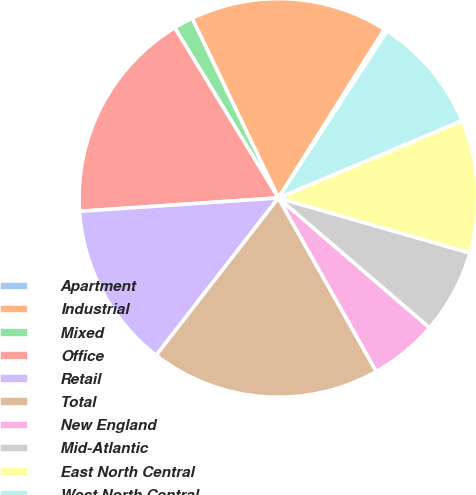Convert chart. <chart><loc_0><loc_0><loc_500><loc_500><pie_chart><fcel>Apartment<fcel>Industrial<fcel>Mixed<fcel>Office<fcel>Retail<fcel>Total<fcel>New England<fcel>Mid-Atlantic<fcel>East North Central<fcel>West North Central<nl><fcel>0.27%<fcel>16.05%<fcel>1.58%<fcel>17.36%<fcel>13.42%<fcel>18.68%<fcel>5.53%<fcel>6.84%<fcel>10.79%<fcel>9.47%<nl></chart> 